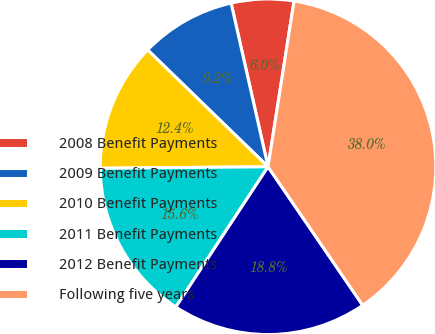<chart> <loc_0><loc_0><loc_500><loc_500><pie_chart><fcel>2008 Benefit Payments<fcel>2009 Benefit Payments<fcel>2010 Benefit Payments<fcel>2011 Benefit Payments<fcel>2012 Benefit Payments<fcel>Following five years<nl><fcel>6.01%<fcel>9.21%<fcel>12.4%<fcel>15.6%<fcel>18.8%<fcel>37.98%<nl></chart> 